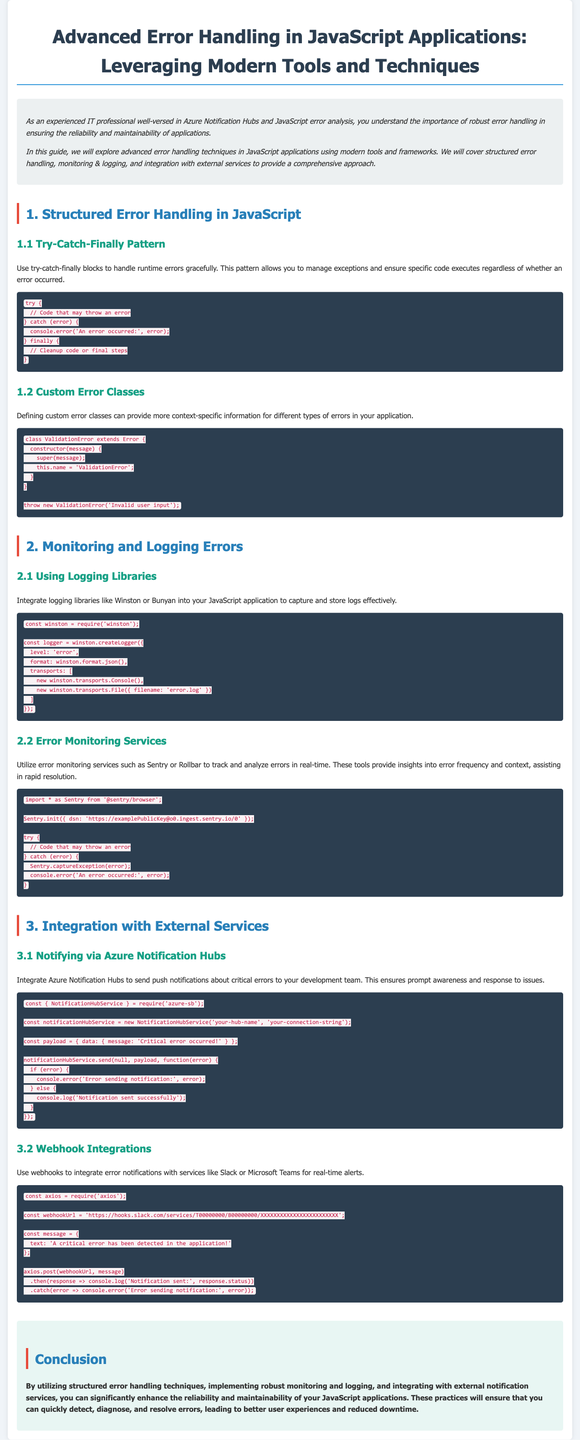What is the main topic of the guide? The main topic is about advanced error handling techniques in JavaScript applications, utilizing modern tools and techniques.
Answer: Advanced Error Handling in JavaScript Applications What are the three main sections covered in the guide? The guide covers structured error handling, monitoring & logging, and integration with external services.
Answer: Structured error handling, monitoring & logging, integration with external services What logging libraries are mentioned for use in JavaScript applications? The guide specifically mentions logging libraries like Winston and Bunyan.
Answer: Winston or Bunyan What pattern allows you to manage exceptions and ensure specific code executes? The pattern referred to is the try-catch-finally pattern.
Answer: Try-Catch-Finally Pattern Which service is suggested for real-time error monitoring? The guide suggests using error monitoring services such as Sentry or Rollbar for real-time error tracking.
Answer: Sentry or Rollbar What is the purpose of custom error classes? Custom error classes provide more context-specific information for different types of errors.
Answer: More context-specific information What is the name of the class for validation errors created in the guide? The name of the class for validation errors is ValidationError.
Answer: ValidationError What Azure service is recommended for sending notifications about critical errors? The guide recommends integrating Azure Notification Hubs for sending notifications.
Answer: Azure Notification Hubs What type of alert can be set up using webhooks mentioned in the guide? Webhooks can be used for real-time alerts to services like Slack or Microsoft Teams.
Answer: Real-time alerts 